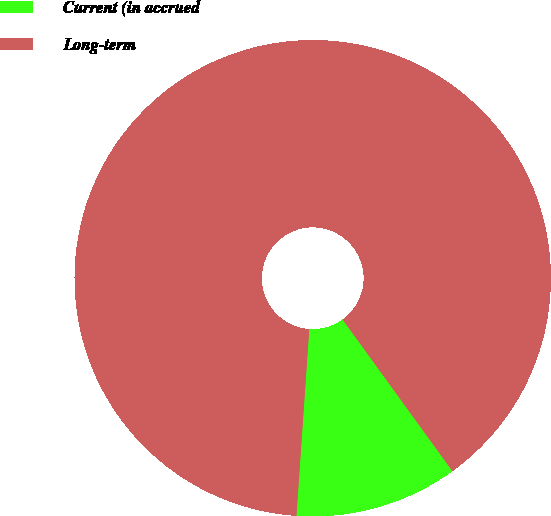Convert chart. <chart><loc_0><loc_0><loc_500><loc_500><pie_chart><fcel>Current (in accrued<fcel>Long-term<nl><fcel>11.07%<fcel>88.93%<nl></chart> 